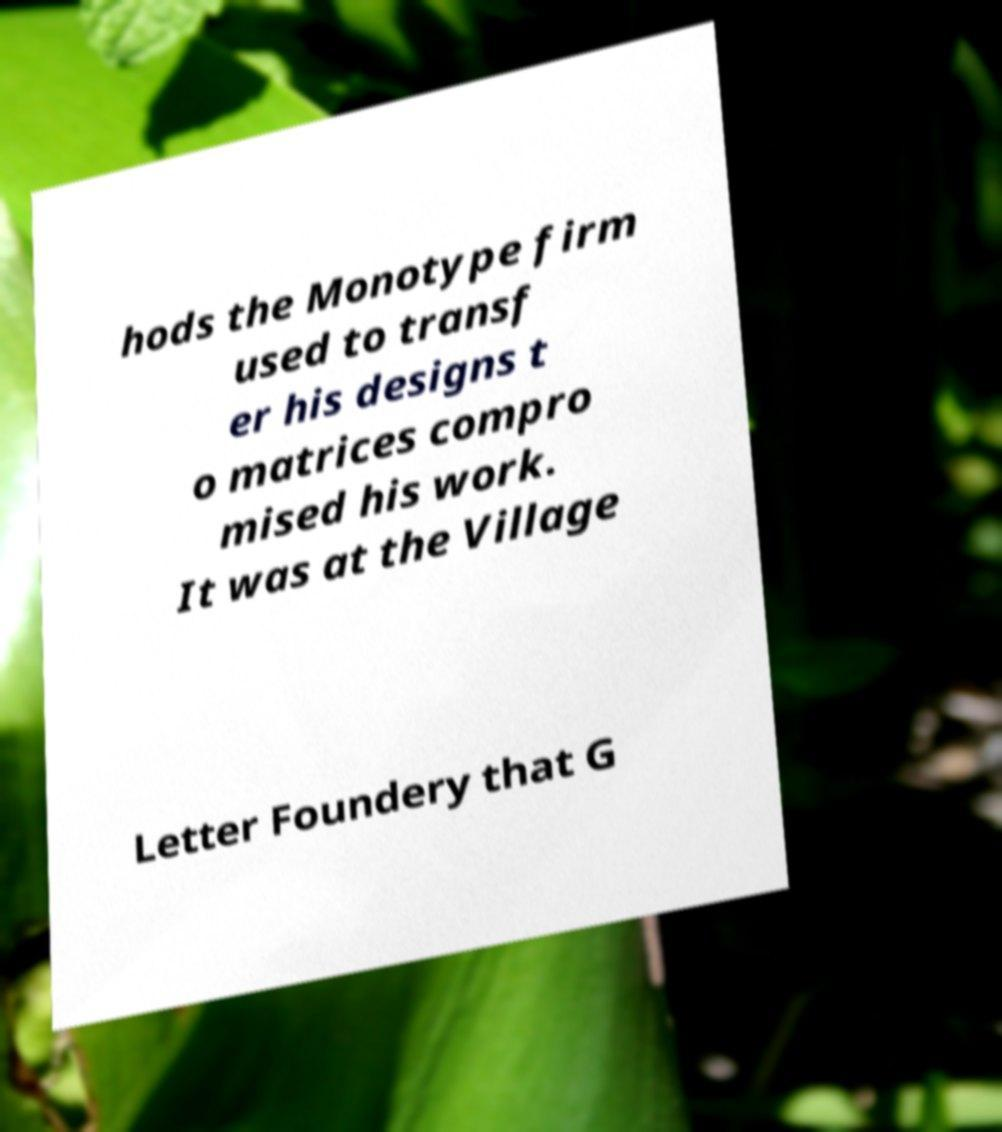What messages or text are displayed in this image? I need them in a readable, typed format. hods the Monotype firm used to transf er his designs t o matrices compro mised his work. It was at the Village Letter Foundery that G 